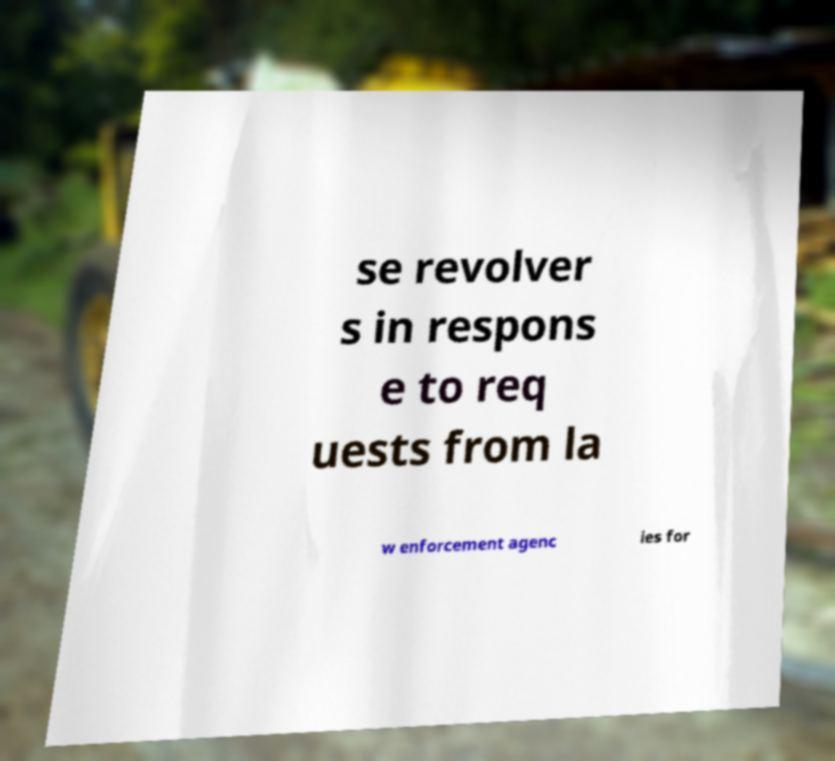Can you read and provide the text displayed in the image?This photo seems to have some interesting text. Can you extract and type it out for me? se revolver s in respons e to req uests from la w enforcement agenc ies for 